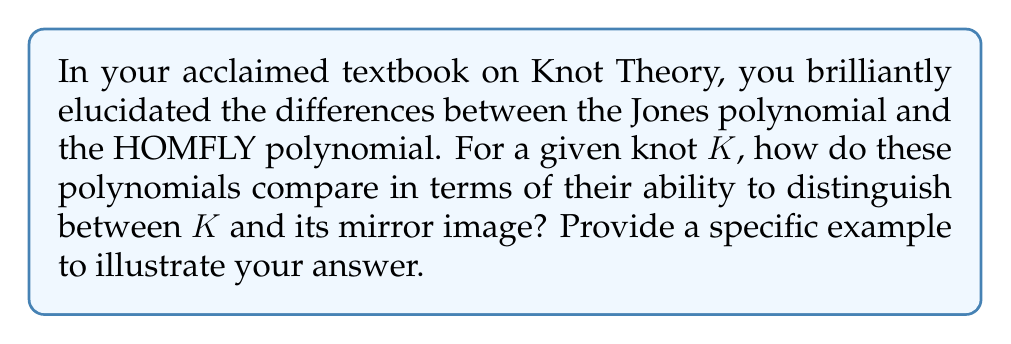Could you help me with this problem? To compare the Jones polynomial and the HOMFLY polynomial in terms of their ability to distinguish between a knot and its mirror image, we need to consider their properties:

1. Jones polynomial:
   - Denoted as $V_K(t)$ for a knot K
   - It is an invariant of oriented knots and links
   - For a knot K and its mirror image K*, the relationship is:
     $V_{K^*}(t) = V_K(t^{-1})$

2. HOMFLY polynomial:
   - Denoted as $P_K(a,z)$ for a knot K
   - It is a two-variable polynomial and a generalization of the Jones polynomial
   - For a knot K and its mirror image K*, the relationship is:
     $P_{K^*}(a,z) = P_K(a^{-1},z)$

3. Comparison:
   - The Jones polynomial can sometimes fail to distinguish between a knot and its mirror image when $V_K(t) = V_K(t^{-1})$
   - The HOMFLY polynomial is generally more powerful in distinguishing knots from their mirror images due to its additional variable

4. Example: Consider the knot 8_17 (in Rolfsen notation)
   - Jones polynomial: $V_{8_{17}}(t) = t^{-3} - t^{-2} + t^{-1} - 1 + t - t^2 + t^3$
   - This polynomial is symmetric, so $V_{8_{17}}(t) = V_{8_{17}}(t^{-1})$
   - The Jones polynomial fails to distinguish 8_17 from its mirror image

   - HOMFLY polynomial: 
     $P_{8_{17}}(a,z) = -a^{-4} + a^{-2}z^2 + 2a^{-2} - z^2 - 1 + a^2z^2 + 2a^2 - a^4$
   - This polynomial is not symmetric in $a$, so $P_{8_{17}}(a,z) \neq P_{8_{17}}(a^{-1},z)$
   - The HOMFLY polynomial successfully distinguishes 8_17 from its mirror image

Therefore, the HOMFLY polynomial is more effective in distinguishing between a knot and its mirror image in this case.
Answer: The HOMFLY polynomial is generally more powerful in distinguishing knots from their mirror images, as demonstrated by the knot 8_17, where the Jones polynomial fails but the HOMFLY polynomial succeeds. 